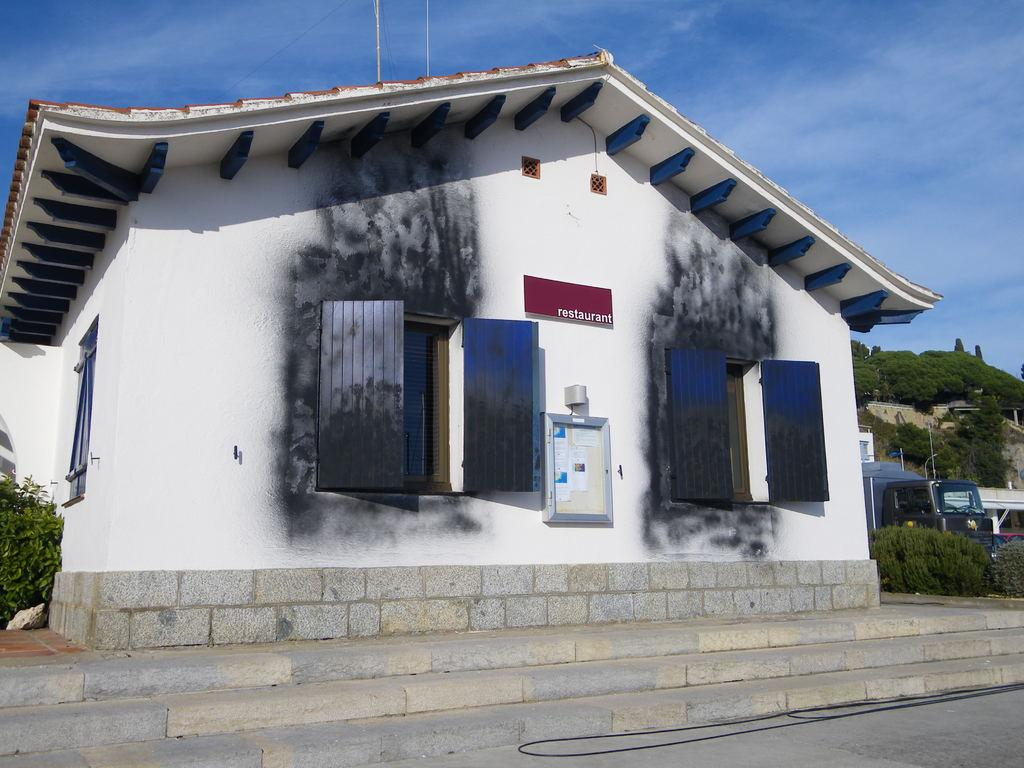What type of structure is visible in the image? There is a house in the image. What are the main features of the house? The house has windows and walls. What is the condition of the windows and walls? The windows and walls appear to be burnt. What is located at the bottom of the image? There is a road at the bottom of the image. What can be seen in the sky at the top of the image? There are clouds in the sky at the top of the image. What type of education or knowledge can be gained from the machine in the image? There is no machine present in the image, so no education or knowledge can be gained from it. 